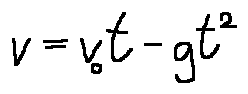<formula> <loc_0><loc_0><loc_500><loc_500>v = v _ { 0 } t - g t ^ { 2 }</formula> 